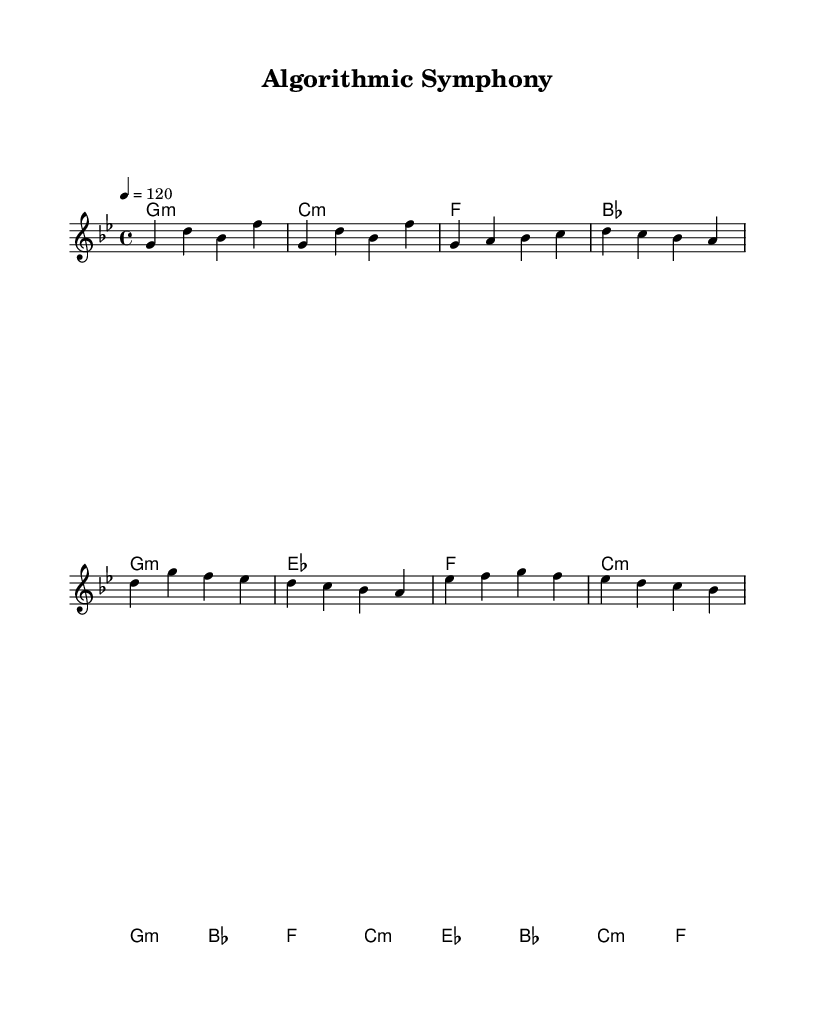What is the key signature of this music? The key signature indicated at the beginning of the score is G minor, which has two flats (B flat and E flat).
Answer: G minor What is the time signature of this music? The time signature is shown as 4/4 in the score, meaning there are four beats in each measure and the quarter note receives one beat.
Answer: 4/4 What is the tempo marking of this music? The tempo marking indicates a speed of quarter note = 120 beats per minute, which is a moderate tempo.
Answer: 120 How many sections does the composition have? The composition consists of four distinct sections: Intro, Verse, Chorus, and Bridge, as indicated in the melody notation.
Answer: Four Which chord follows the Intro section? The harmonies in the Intro section are G minor and C minor, and following this, the verse starts with G minor and E flat.
Answer: G minor What type of harmonies are used primarily in this composition? The majority of the harmonic structure utilizes minor chords, which create a more somber and reflective mood typical in both classical and electronic music.
Answer: Minor How is the melody organized structurally? The melody is structured in short phrases corresponding to the sections, with specific notes in each section contributing to the overall contour, matching the provided harmonic progression.
Answer: Short phrases 